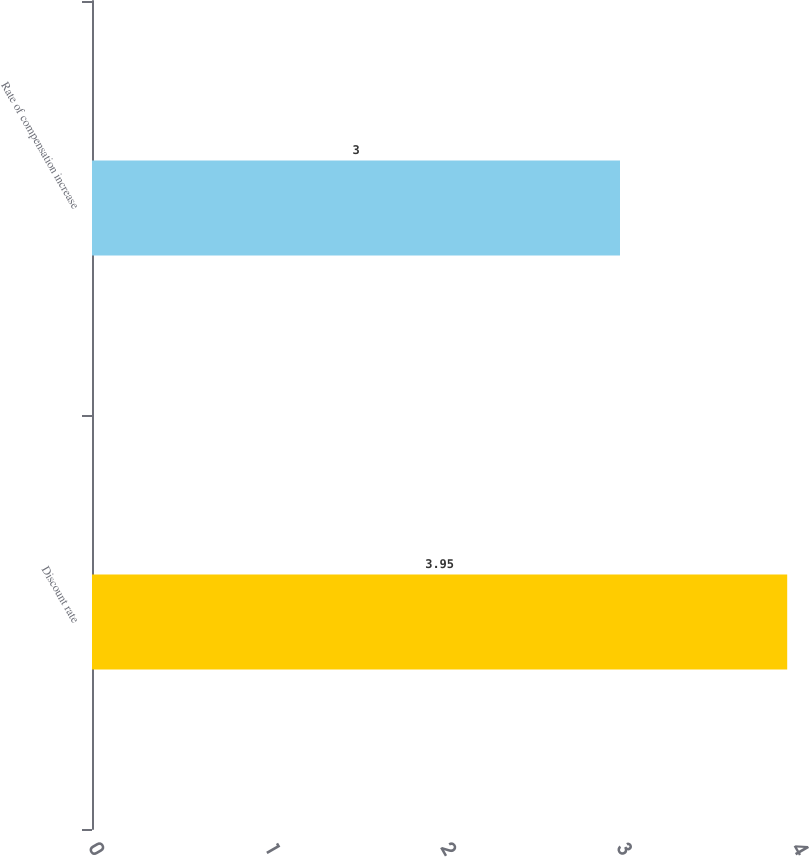Convert chart. <chart><loc_0><loc_0><loc_500><loc_500><bar_chart><fcel>Discount rate<fcel>Rate of compensation increase<nl><fcel>3.95<fcel>3<nl></chart> 